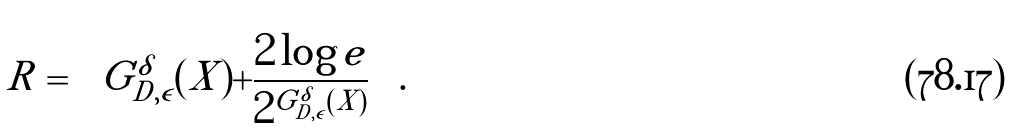Convert formula to latex. <formula><loc_0><loc_0><loc_500><loc_500>R = \left \lfloor G _ { D , \epsilon } ^ { \delta } ( X ) + \frac { 2 \log e } { 2 ^ { G _ { D , \epsilon } ^ { \delta } ( X ) } } \right \rfloor .</formula> 